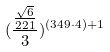Convert formula to latex. <formula><loc_0><loc_0><loc_500><loc_500>( \frac { \frac { \sqrt { 6 } } { 2 2 1 } } { 3 } ) ^ { ( 3 4 9 \cdot 4 ) + 1 }</formula> 